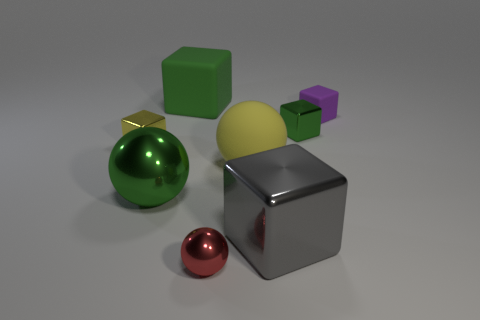How many things are objects behind the tiny metal ball or small metal blocks to the right of the tiny yellow shiny cube?
Make the answer very short. 7. What is the color of the other matte object that is the same shape as the small matte thing?
Your response must be concise. Green. What number of shiny cubes have the same color as the big matte sphere?
Make the answer very short. 1. Does the matte sphere have the same color as the big metallic block?
Offer a very short reply. No. What number of things are either rubber blocks that are behind the yellow metallic cube or purple matte cylinders?
Your response must be concise. 2. The block in front of the small object that is left of the large matte thing that is behind the yellow metal block is what color?
Make the answer very short. Gray. The large object that is the same material as the gray cube is what color?
Provide a succinct answer. Green. How many big things have the same material as the tiny purple object?
Provide a succinct answer. 2. Does the green cube right of the red thing have the same size as the yellow sphere?
Offer a terse response. No. What is the color of the rubber cube that is the same size as the green metal sphere?
Offer a very short reply. Green. 